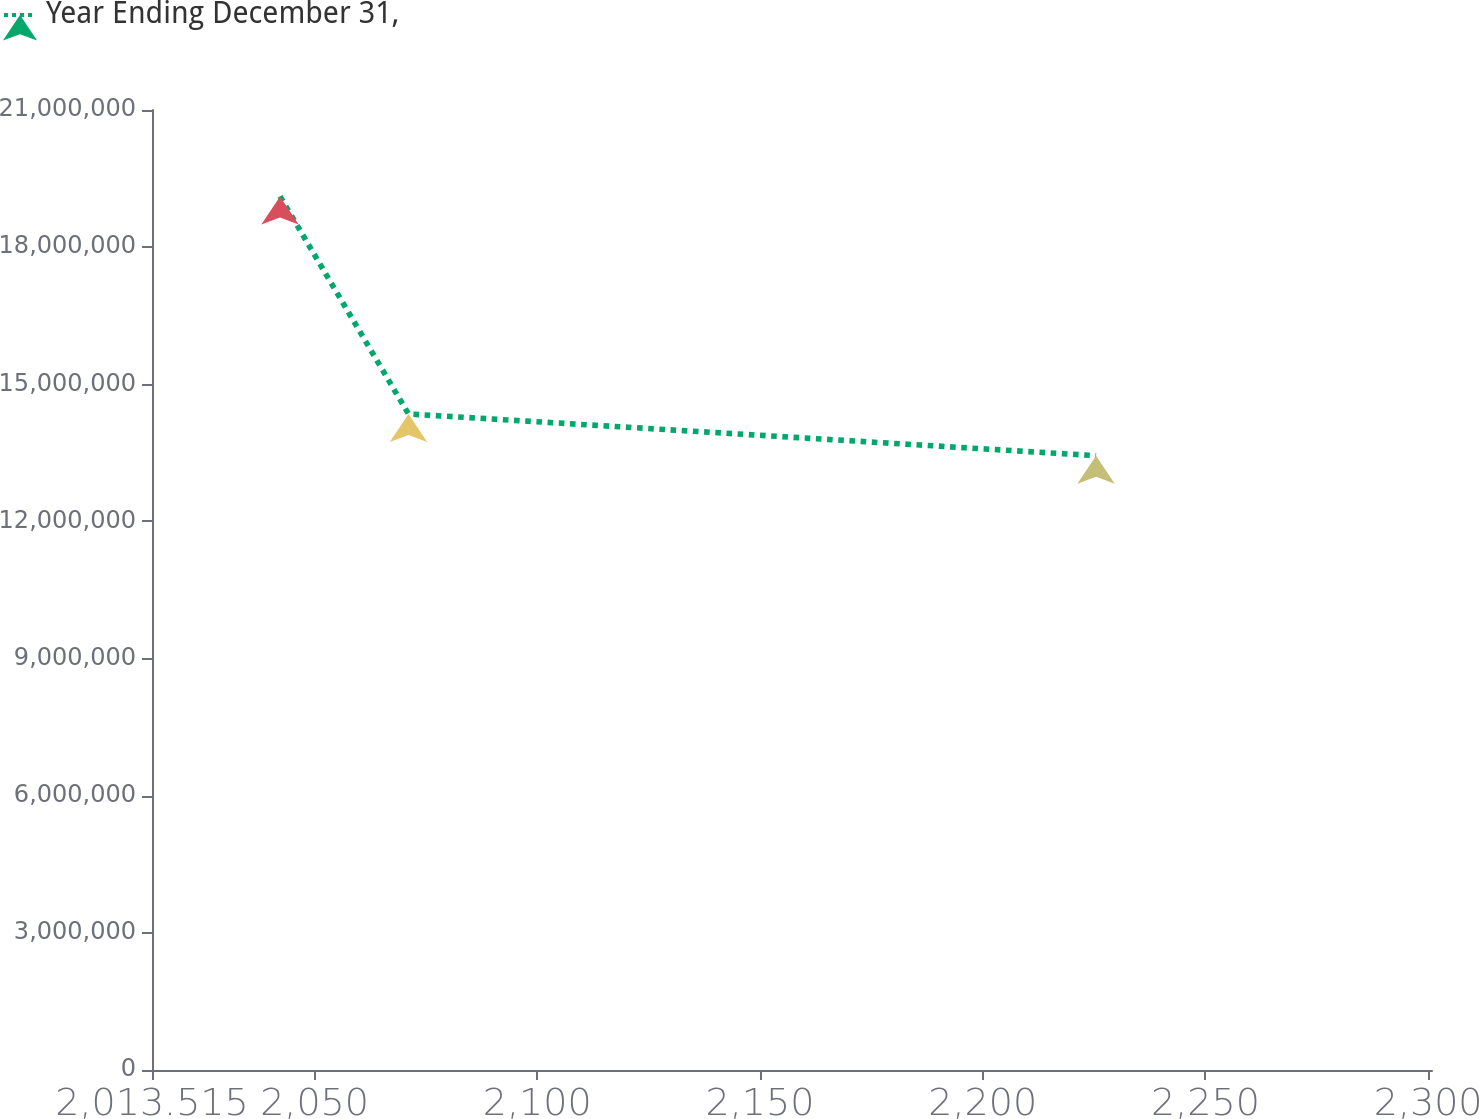Convert chart. <chart><loc_0><loc_0><loc_500><loc_500><line_chart><ecel><fcel>Year Ending December 31,<nl><fcel>2042.25<fcel>1.91094e+07<nl><fcel>2071.09<fcel>1.43512e+07<nl><fcel>2225.45<fcel>1.34378e+07<nl><fcel>2301.07<fcel>9.97533e+06<nl><fcel>2329.6<fcel>1.10631e+07<nl></chart> 